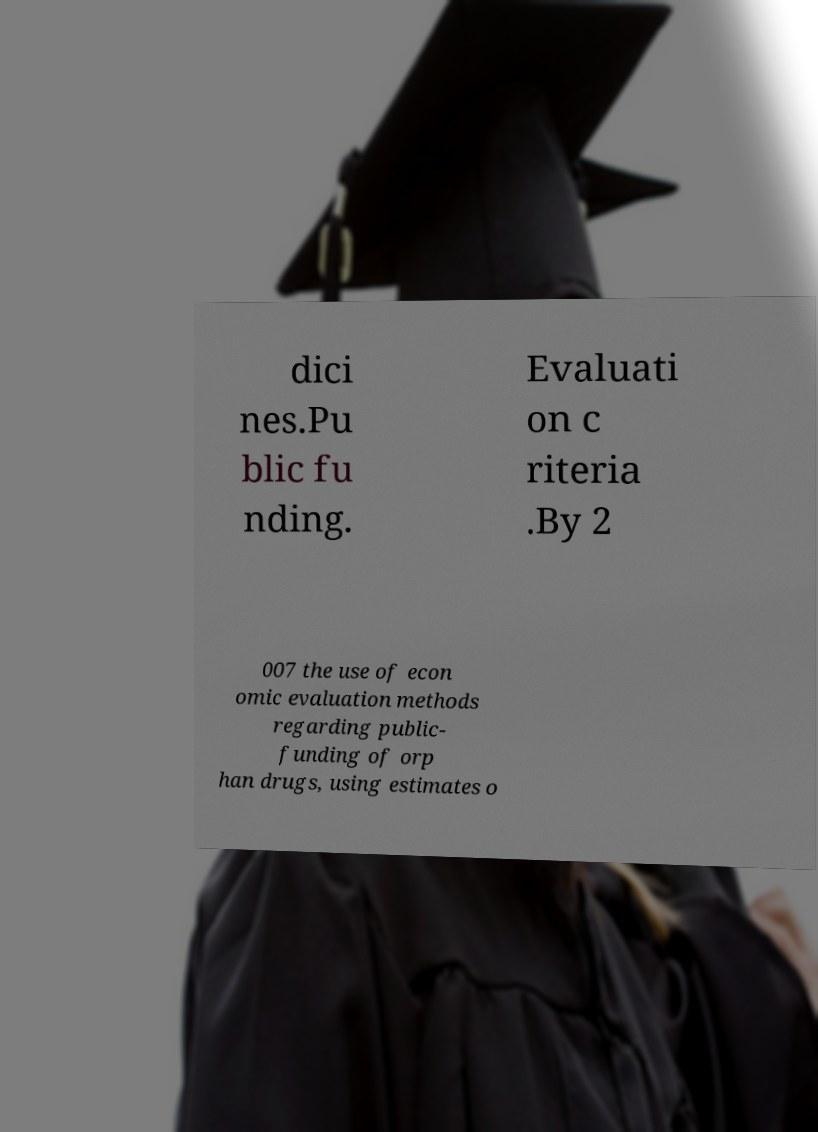Please read and relay the text visible in this image. What does it say? dici nes.Pu blic fu nding. Evaluati on c riteria .By 2 007 the use of econ omic evaluation methods regarding public- funding of orp han drugs, using estimates o 